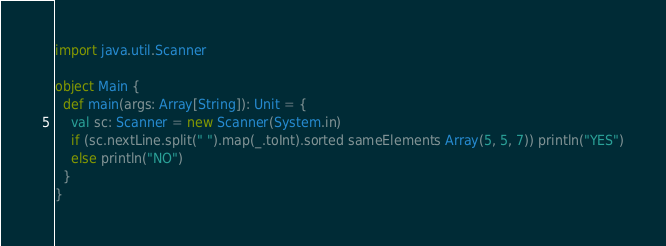Convert code to text. <code><loc_0><loc_0><loc_500><loc_500><_Scala_>import java.util.Scanner

object Main {
  def main(args: Array[String]): Unit = {
    val sc: Scanner = new Scanner(System.in)
    if (sc.nextLine.split(" ").map(_.toInt).sorted sameElements Array(5, 5, 7)) println("YES")
    else println("NO")
  }
}
</code> 